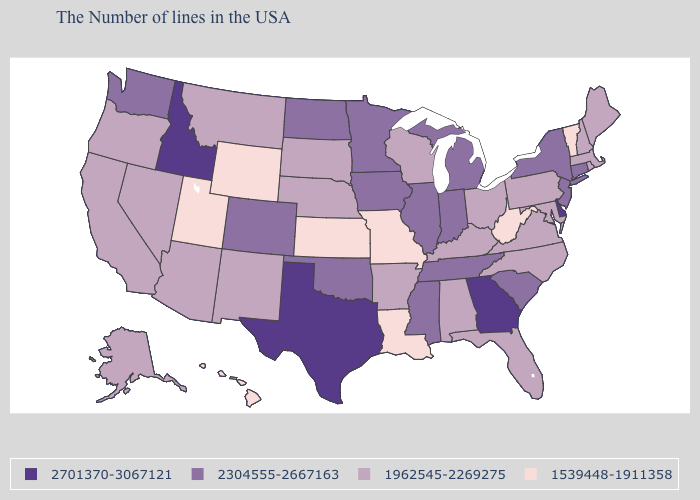Name the states that have a value in the range 2701370-3067121?
Be succinct. Delaware, Georgia, Texas, Idaho. What is the highest value in the South ?
Keep it brief. 2701370-3067121. What is the value of Wyoming?
Short answer required. 1539448-1911358. How many symbols are there in the legend?
Short answer required. 4. Name the states that have a value in the range 2304555-2667163?
Short answer required. Connecticut, New York, New Jersey, South Carolina, Michigan, Indiana, Tennessee, Illinois, Mississippi, Minnesota, Iowa, Oklahoma, North Dakota, Colorado, Washington. Does Hawaii have the lowest value in the USA?
Give a very brief answer. Yes. Name the states that have a value in the range 2304555-2667163?
Be succinct. Connecticut, New York, New Jersey, South Carolina, Michigan, Indiana, Tennessee, Illinois, Mississippi, Minnesota, Iowa, Oklahoma, North Dakota, Colorado, Washington. What is the value of Alabama?
Answer briefly. 1962545-2269275. Does Colorado have the lowest value in the USA?
Short answer required. No. What is the value of North Dakota?
Quick response, please. 2304555-2667163. Which states have the lowest value in the USA?
Concise answer only. Vermont, West Virginia, Louisiana, Missouri, Kansas, Wyoming, Utah, Hawaii. Name the states that have a value in the range 1962545-2269275?
Be succinct. Maine, Massachusetts, Rhode Island, New Hampshire, Maryland, Pennsylvania, Virginia, North Carolina, Ohio, Florida, Kentucky, Alabama, Wisconsin, Arkansas, Nebraska, South Dakota, New Mexico, Montana, Arizona, Nevada, California, Oregon, Alaska. Which states have the lowest value in the USA?
Answer briefly. Vermont, West Virginia, Louisiana, Missouri, Kansas, Wyoming, Utah, Hawaii. What is the lowest value in states that border Kentucky?
Give a very brief answer. 1539448-1911358. Does the first symbol in the legend represent the smallest category?
Short answer required. No. 